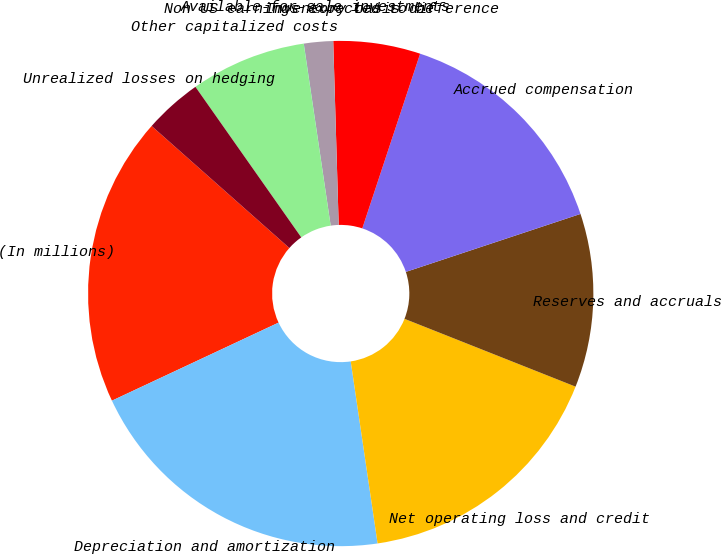<chart> <loc_0><loc_0><loc_500><loc_500><pie_chart><fcel>(In millions)<fcel>Depreciation and amortization<fcel>Net operating loss and credit<fcel>Reserves and accruals<fcel>Accrued compensation<fcel>Inventory basis difference<fcel>Available-for-sale investments<fcel>Non US earnings expected to be<fcel>Other capitalized costs<fcel>Unrealized losses on hedging<nl><fcel>18.51%<fcel>20.36%<fcel>16.66%<fcel>11.11%<fcel>14.81%<fcel>5.56%<fcel>1.86%<fcel>0.01%<fcel>7.41%<fcel>3.71%<nl></chart> 